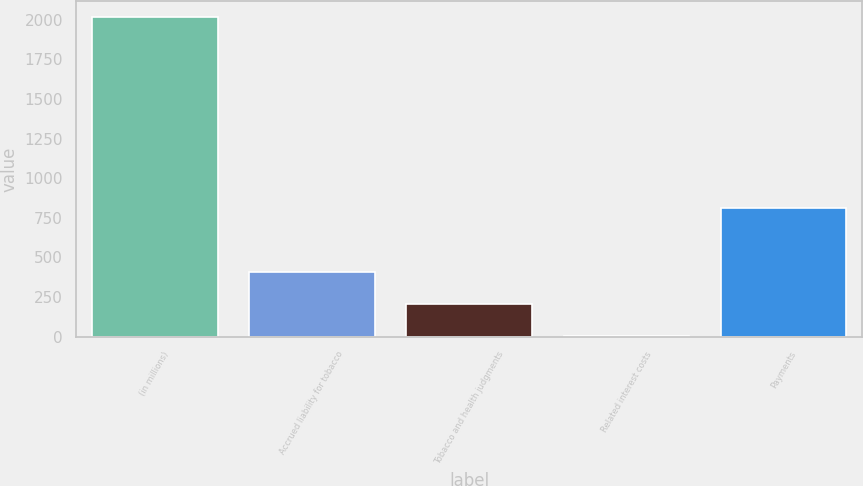Convert chart to OTSL. <chart><loc_0><loc_0><loc_500><loc_500><bar_chart><fcel>(in millions)<fcel>Accrued liability for tobacco<fcel>Tobacco and health judgments<fcel>Related interest costs<fcel>Payments<nl><fcel>2016<fcel>408.8<fcel>207.9<fcel>7<fcel>810.6<nl></chart> 